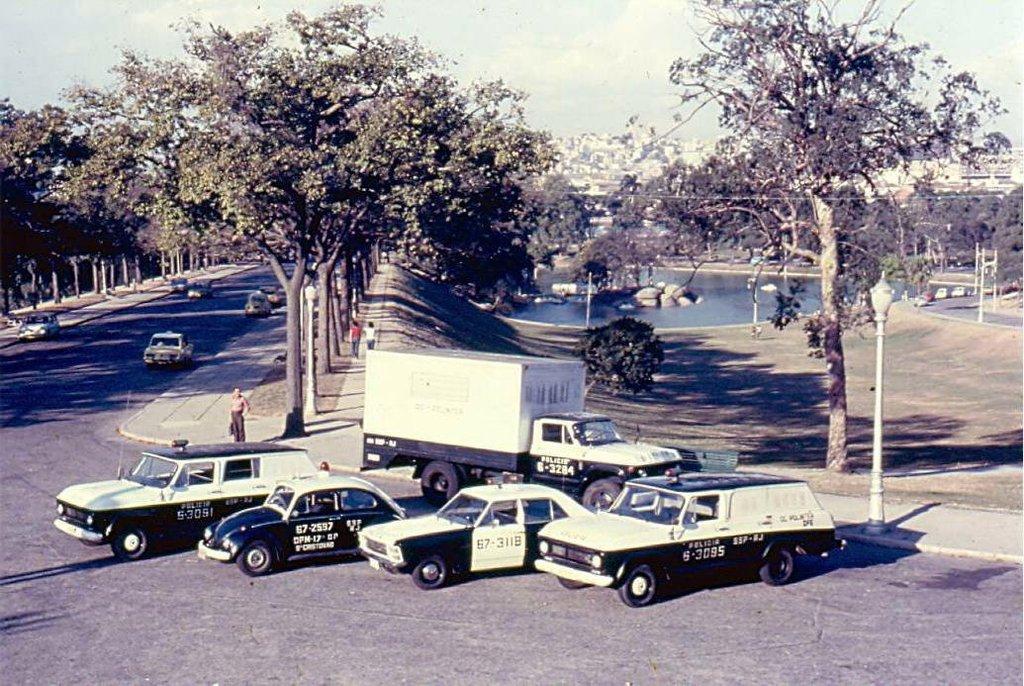Please provide a concise description of this image. In the picture we can see a road, on both the sides of the road we can see trees and a path and we can see some people walking on it we can see some vehicles on the road and some are parked and behind it we can see a path and far away from it we can see the water surface and in the water we can see some stones and in the background we can see houses, buildings and the sky with clouds. 